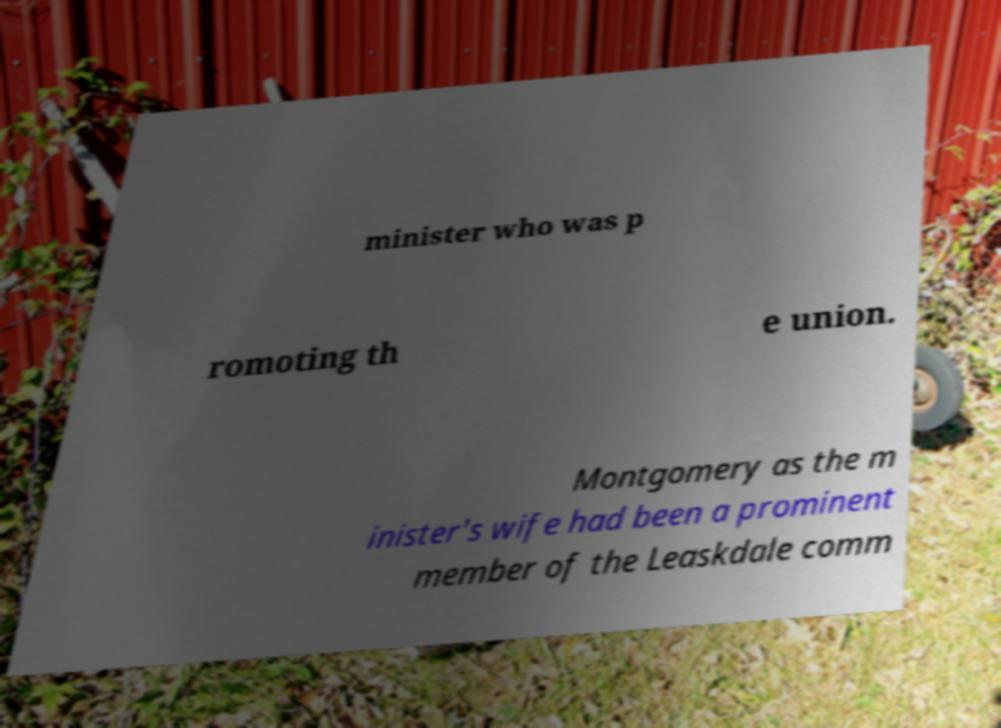What messages or text are displayed in this image? I need them in a readable, typed format. minister who was p romoting th e union. Montgomery as the m inister's wife had been a prominent member of the Leaskdale comm 